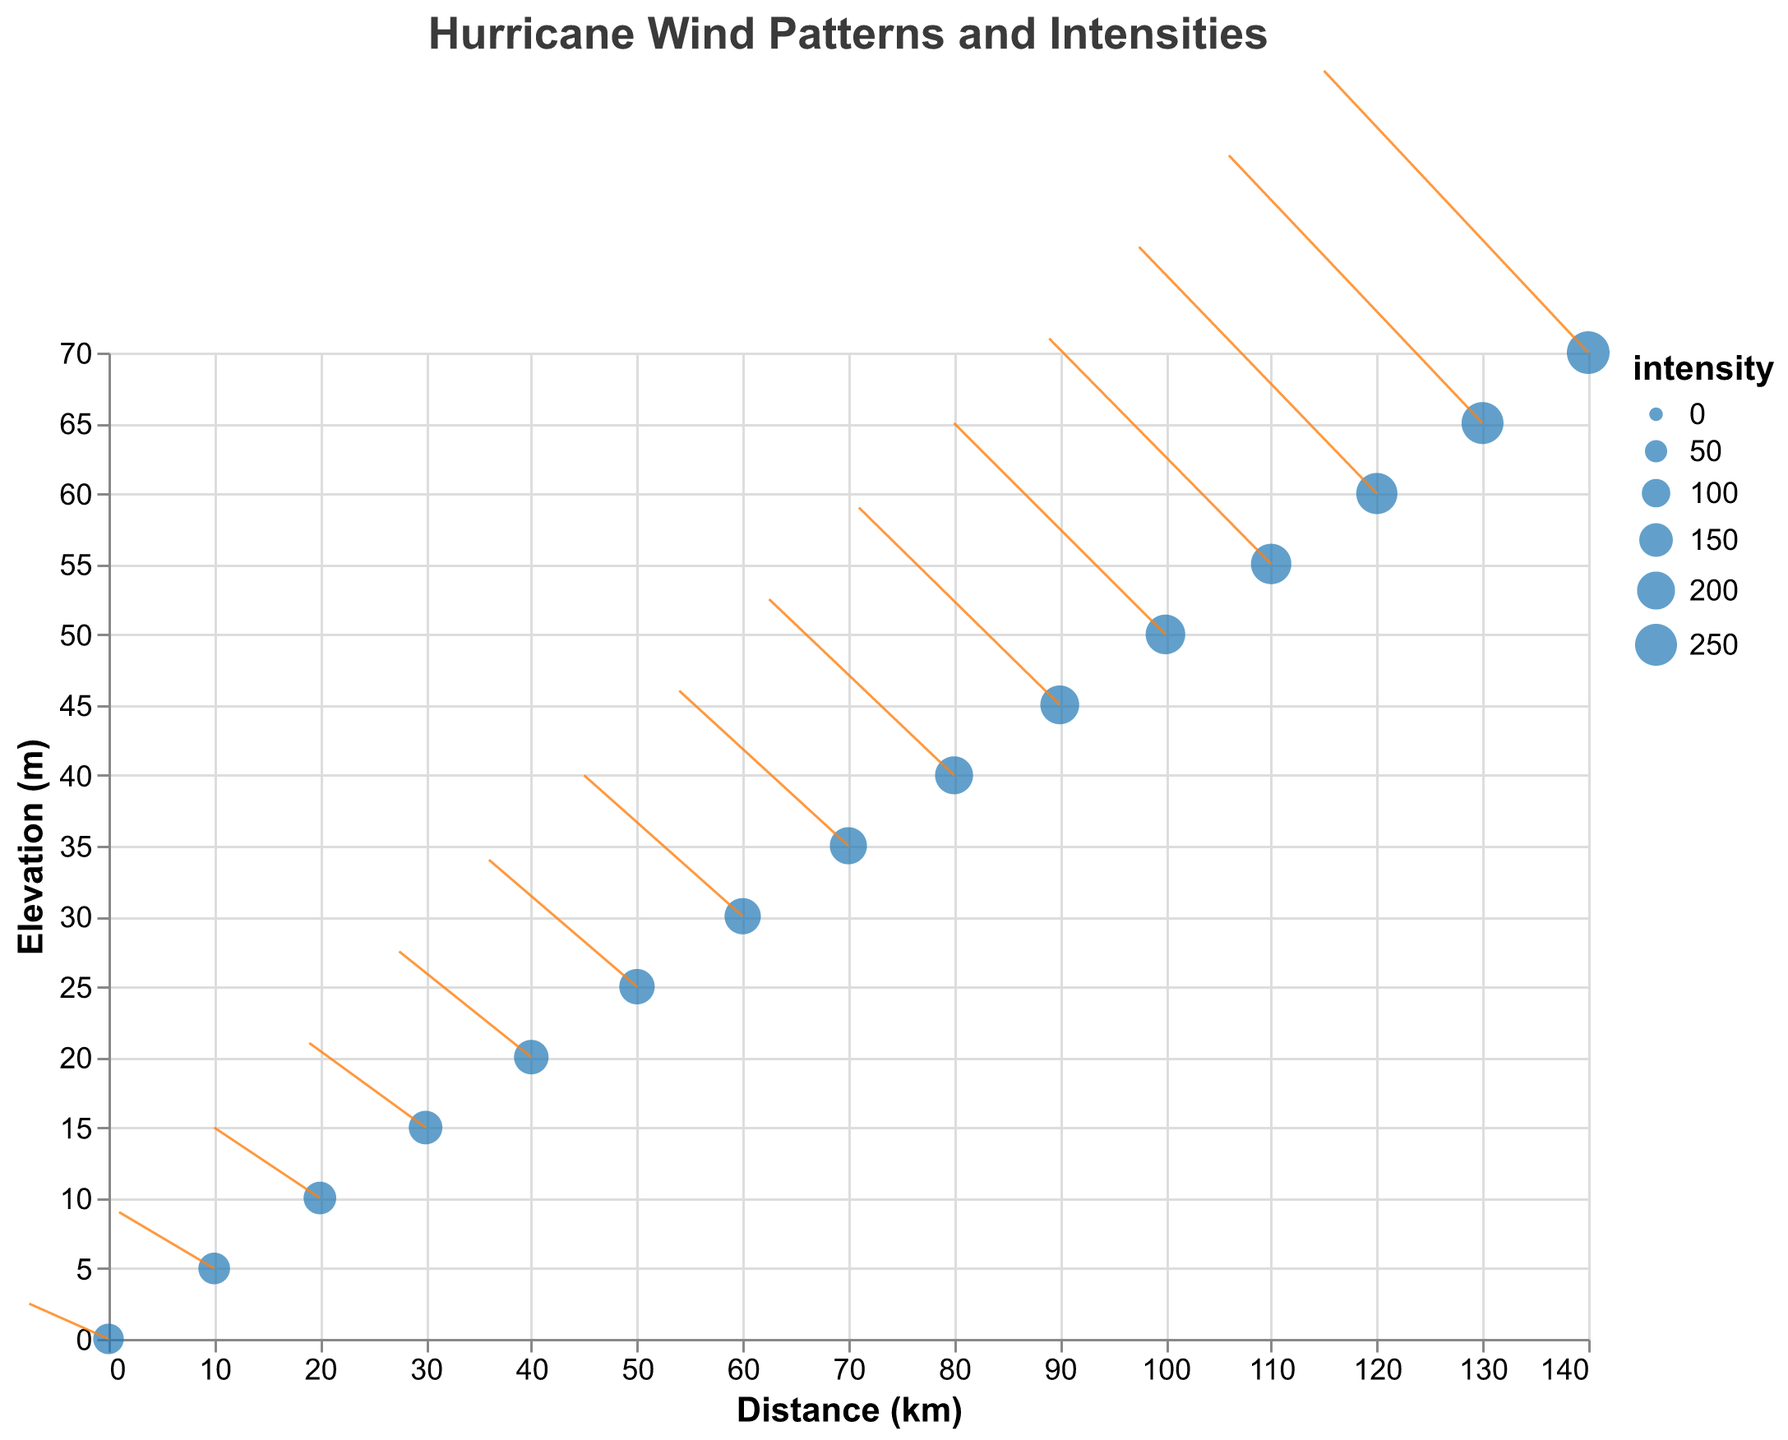What is the title of the figure? The title is prominently displayed at the top of the figure in bold text.
Answer: Hurricane Wind Patterns and Intensities How many data points are there in the figure? Count the individual points displayed on the quiver plot.
Answer: 15 Which region shows the highest wind intensity? The size of the points represents the wind intensity, with larger points indicating higher intensities. The largest point appears at coordinates (140, 70).
Answer: (140, 70) What is the wind direction at the point (20,10)? The direction of the wind at a point can be determined by the orientation of the arrows (rule marks). At (20, 10), the arrow points towards the left with a slight upward tilt.
Answer: Left and Up Which point has the weakest wind intensity and what is that intensity? The smallest point corresponds to the weakest intensity, located at (0, 0). Checking its size in comparison with others, it is the smallest.
Answer: (0, 0), intensity 120 What is the difference in wind intensity between the points (50,25) and (100,50)? Look at the size of the points and note the intensities from the data. The difference is calculated by 220 - 170.
Answer: 50 What's the average wind intensity of the points at coordinates (0,0), (50,25), and (100,50)? Sum the intensities of the three points and divide by the number of points: (120 + 170 + 220)/3 = 510/3
Answer: 170 How does the wind speed at (80,40) compare to that at (130,65)? Compare the magnitude of the vectors (u,v) at these coordinates. (80, 40) has (-35, 25) and (130, 65) has (-48, 38). Calculate their magnitudes: sqrt((-35)^2 + 25^2) and sqrt((-48)^2 + 38^2)
Answer: Speed at (80,40) is less What is the general trend of wind direction? By observing the overall direction of arrows, it indicates wind predominately moves leftward with varying degrees of upward tilt.
Answer: Leftward and upward 